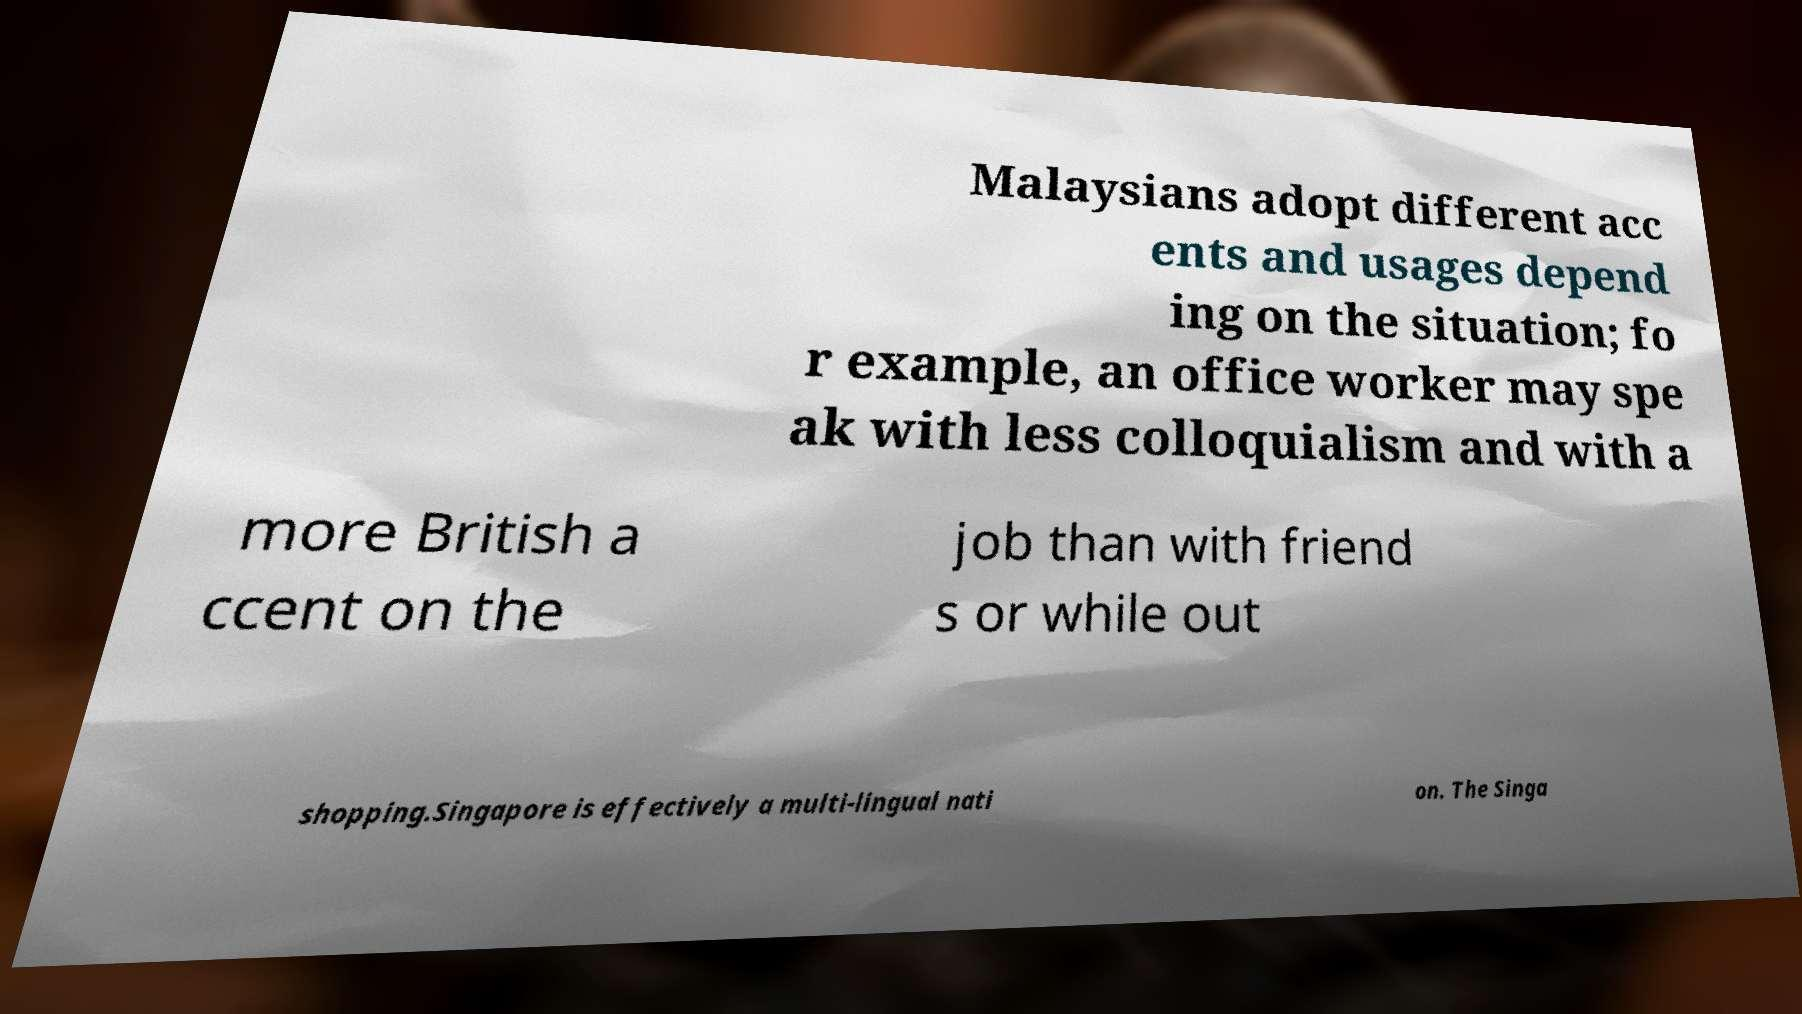Could you assist in decoding the text presented in this image and type it out clearly? Malaysians adopt different acc ents and usages depend ing on the situation; fo r example, an office worker may spe ak with less colloquialism and with a more British a ccent on the job than with friend s or while out shopping.Singapore is effectively a multi-lingual nati on. The Singa 